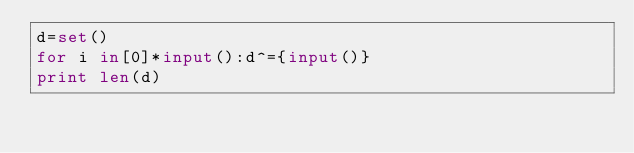Convert code to text. <code><loc_0><loc_0><loc_500><loc_500><_Python_>d=set()
for i in[0]*input():d^={input()}
print len(d)</code> 